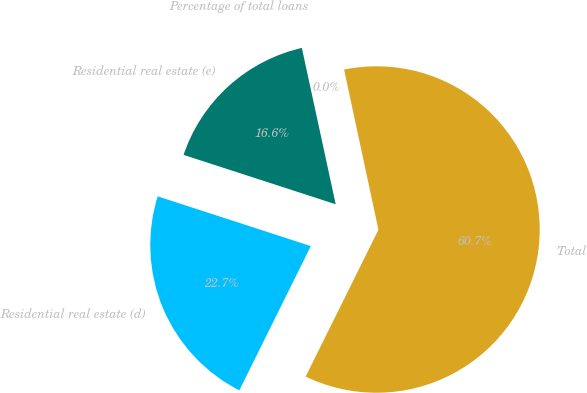<chart> <loc_0><loc_0><loc_500><loc_500><pie_chart><fcel>Residential real estate (d)<fcel>Total<fcel>Percentage of total loans<fcel>Residential real estate (e)<nl><fcel>22.67%<fcel>60.69%<fcel>0.03%<fcel>16.61%<nl></chart> 